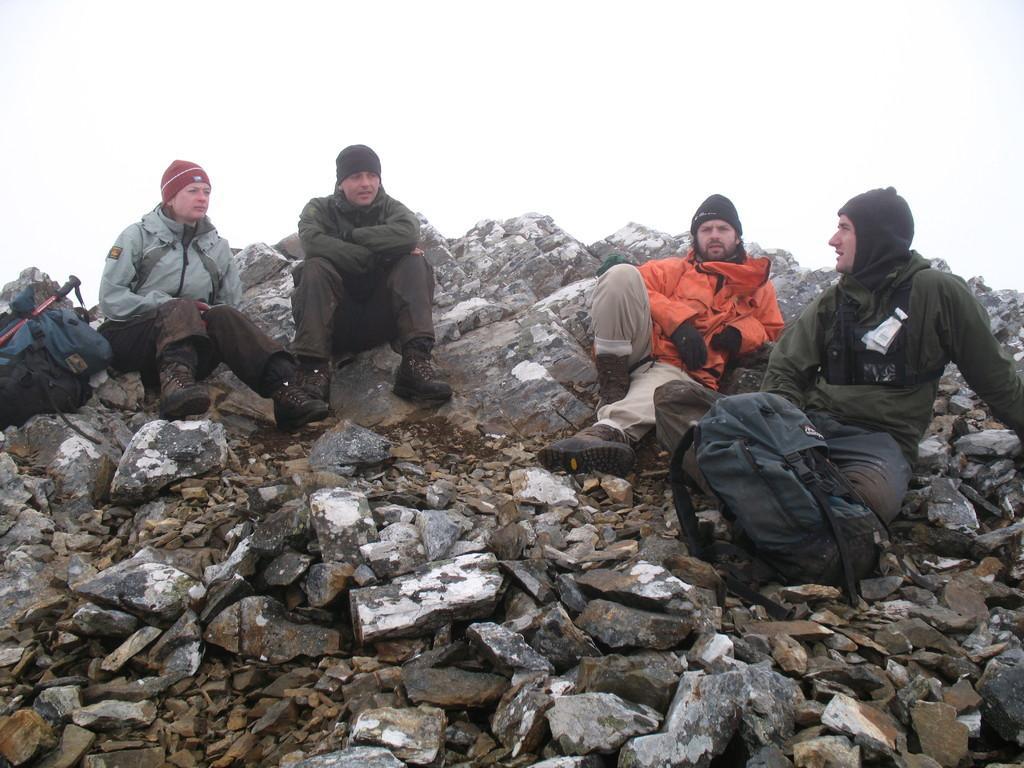Could you give a brief overview of what you see in this image? In this picture, there are four people sitting on the rocks. Two people towards the left and two people sitting towards the right. All of them are wearing jackets and caps. Towards the right, there is a bag. Towards the left, there is another bag. On the top, there is a sky. 